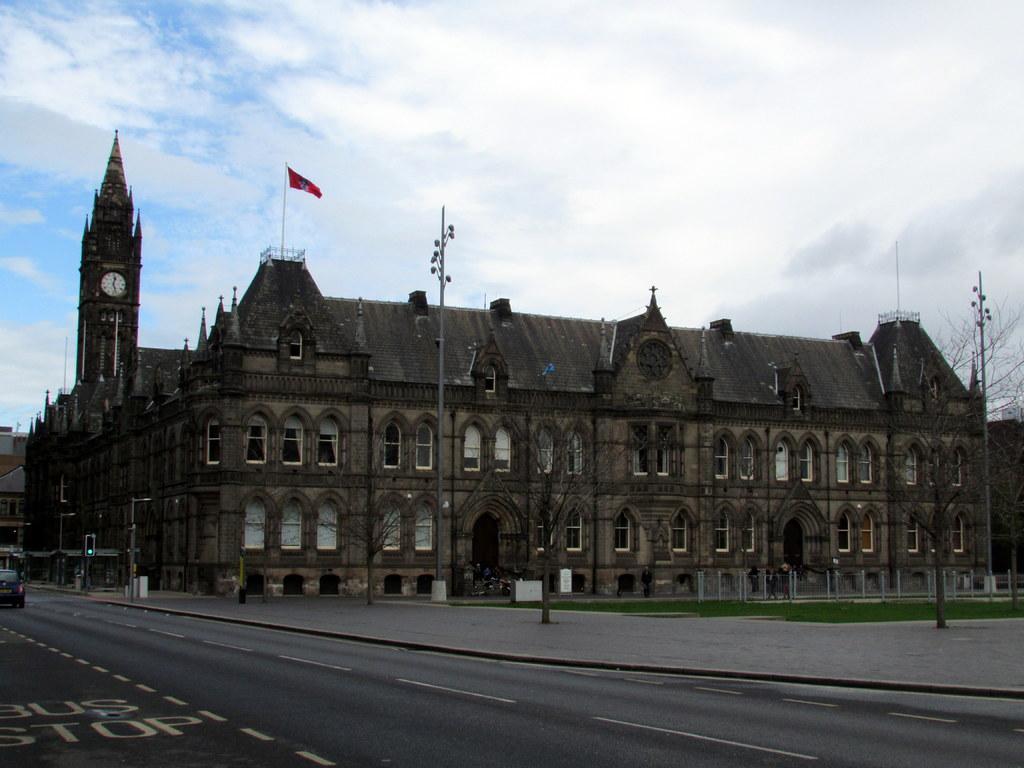Describe this image in one or two sentences. In this image in the center there is a palace, and on the left side there is a clock tower. And on the palace there are poles and flags, at the bottom there is road and also we could see some poles, trees, vehicles, traffic signals and grass. At the top there is sky. 